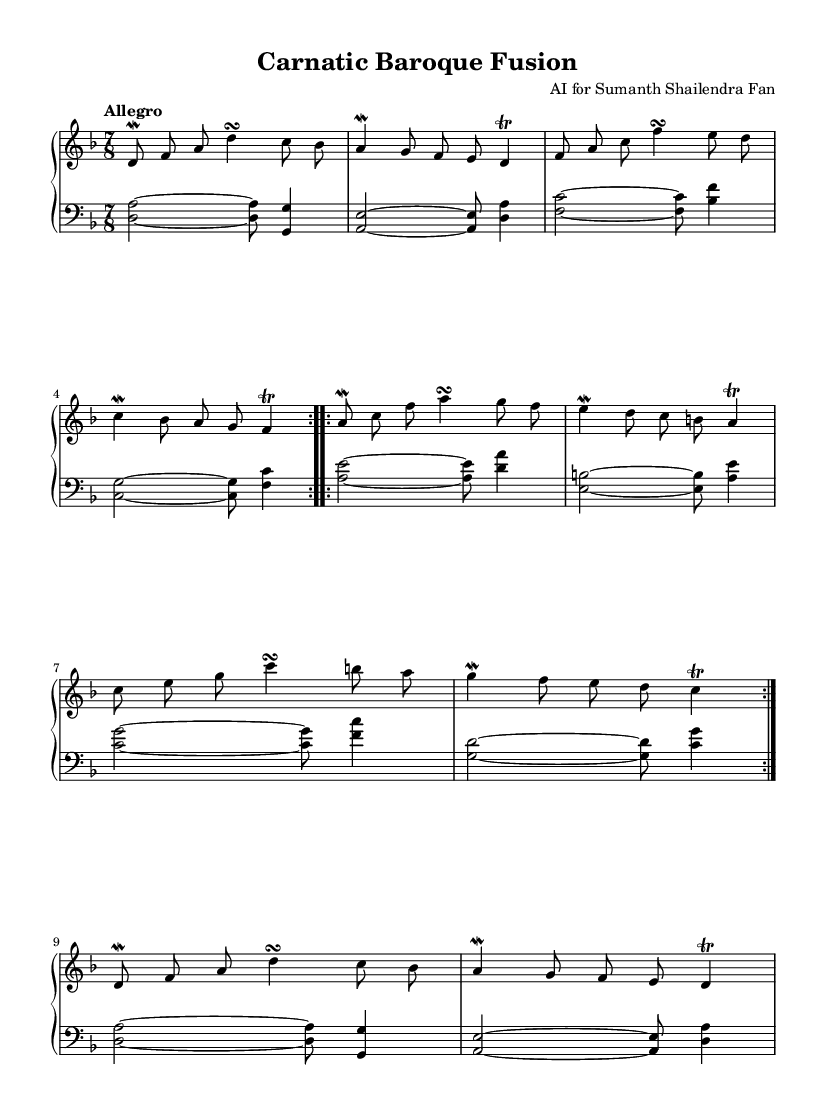What is the key signature of this music? The key signature is D minor, which has one flat (B flat) indicated at the beginning of the staff.
Answer: D minor What is the time signature of this composition? The time signature is 7/8, which is specified at the beginning of the music. This means there are seven beats in each measure, and the eighth note receives one beat.
Answer: 7/8 What is the tempo marking indicated in the score? The tempo marking is "Allegro," which suggests a fast, lively pace for the performance of this piece.
Answer: Allegro How many sections are there in the composition? There are two main sections labeled as A and B, each repeated. Following that, there is a return to an abbreviated Section A.
Answer: Three What ornamental technique is used in the right hand part at the beginning? The right hand part employs a mordent at the start of the music, which is indicated by the symbol before the note. A mordent consists of the principal note, the note immediately below it, and back to the principal note, creating a rapid decorative effect.
Answer: Mordent How many times is Section A repeated? Section A is repeated two times as indicated by the "repeat volta" markings at the beginning and at the end of the section. This means the player should go back to the start of the section after reaching the end.
Answer: Two What is the primary texture of this composition? The primary texture of the composition is polyphonic, as both hands are playing independent melodic lines, typical of Baroque music, creating a rich interweaving of melodies.
Answer: Polyphonic 